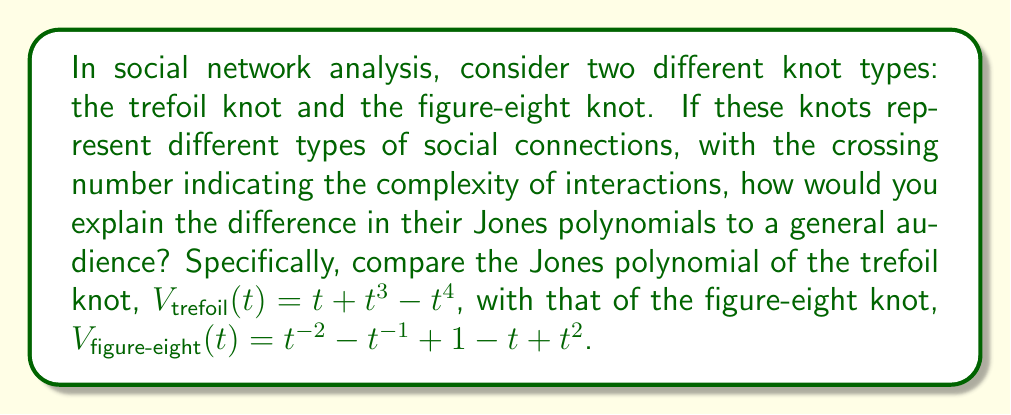Can you answer this question? 1. Interpret the knots:
   - Trefoil knot: simplest non-trivial knot, 3 crossings
   - Figure-eight knot: next simplest knot, 4 crossings

2. Explain Jones polynomials:
   - Mathematical tool to distinguish knots
   - Invariant: same for equivalent knots

3. Compare polynomials:
   - Trefoil: $V_{\text{trefoil}}(t) = t + t^3 - t^4$
   - Figure-eight: $V_{\text{figure-eight}}(t) = t^{-2} - t^{-1} + 1 - t + t^2$

4. Interpret for social networks:
   - Degree of polynomial: related to knot complexity
   - Trefoil: degree 4, simpler interactions
   - Figure-eight: degree 4 (absolute value), more balanced interactions

5. Explain coefficients:
   - Trefoil: all positive except last term
   - Figure-eight: alternating signs, symmetric

6. Social network implications:
   - Trefoil: more unidirectional interactions
   - Figure-eight: more balanced, bidirectional interactions

7. Simplify for general audience:
   - Trefoil: "mostly positive" connections
   - Figure-eight: "give and take" relationships
Answer: The trefoil knot's Jones polynomial suggests simpler, mostly unidirectional interactions in a social network, while the figure-eight knot's polynomial indicates more complex, balanced bidirectional relationships. 